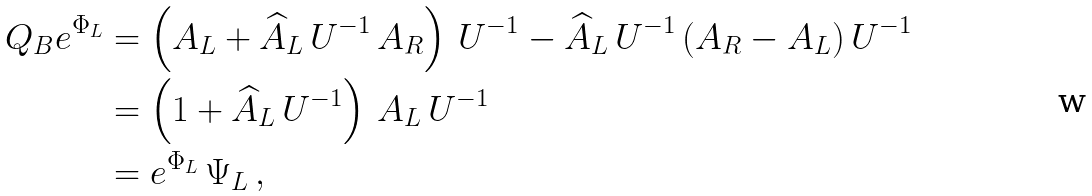<formula> <loc_0><loc_0><loc_500><loc_500>Q _ { B } e ^ { \Phi _ { L } } & = \left ( A _ { L } + \widehat { A } _ { L } \, U ^ { - 1 } \, A _ { R } \right ) \, U ^ { - 1 } - \widehat { A } _ { L } \, U ^ { - 1 } \, ( A _ { R } - A _ { L } ) \, U ^ { - 1 } \\ & = \left ( 1 + \widehat { A } _ { L } \, U ^ { - 1 } \right ) \, A _ { L } \, U ^ { - 1 } \\ & = e ^ { \Phi _ { L } } \, \Psi _ { L } \, ,</formula> 